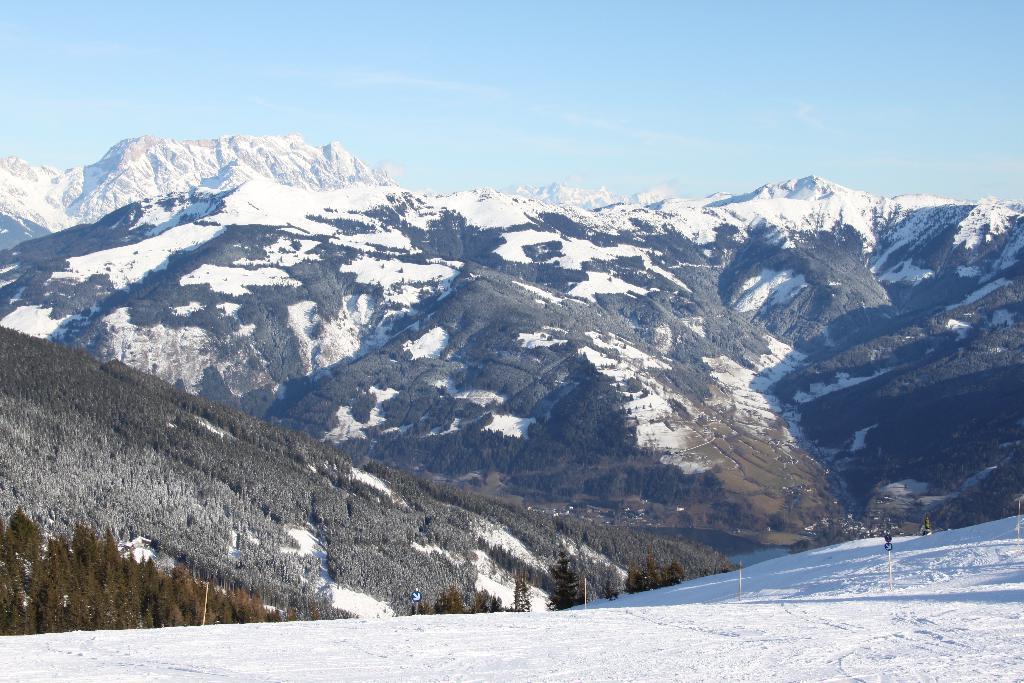Describe this image in one or two sentences. These are the mountains with snow, on the left side there are trees. At the top it's a sky. 